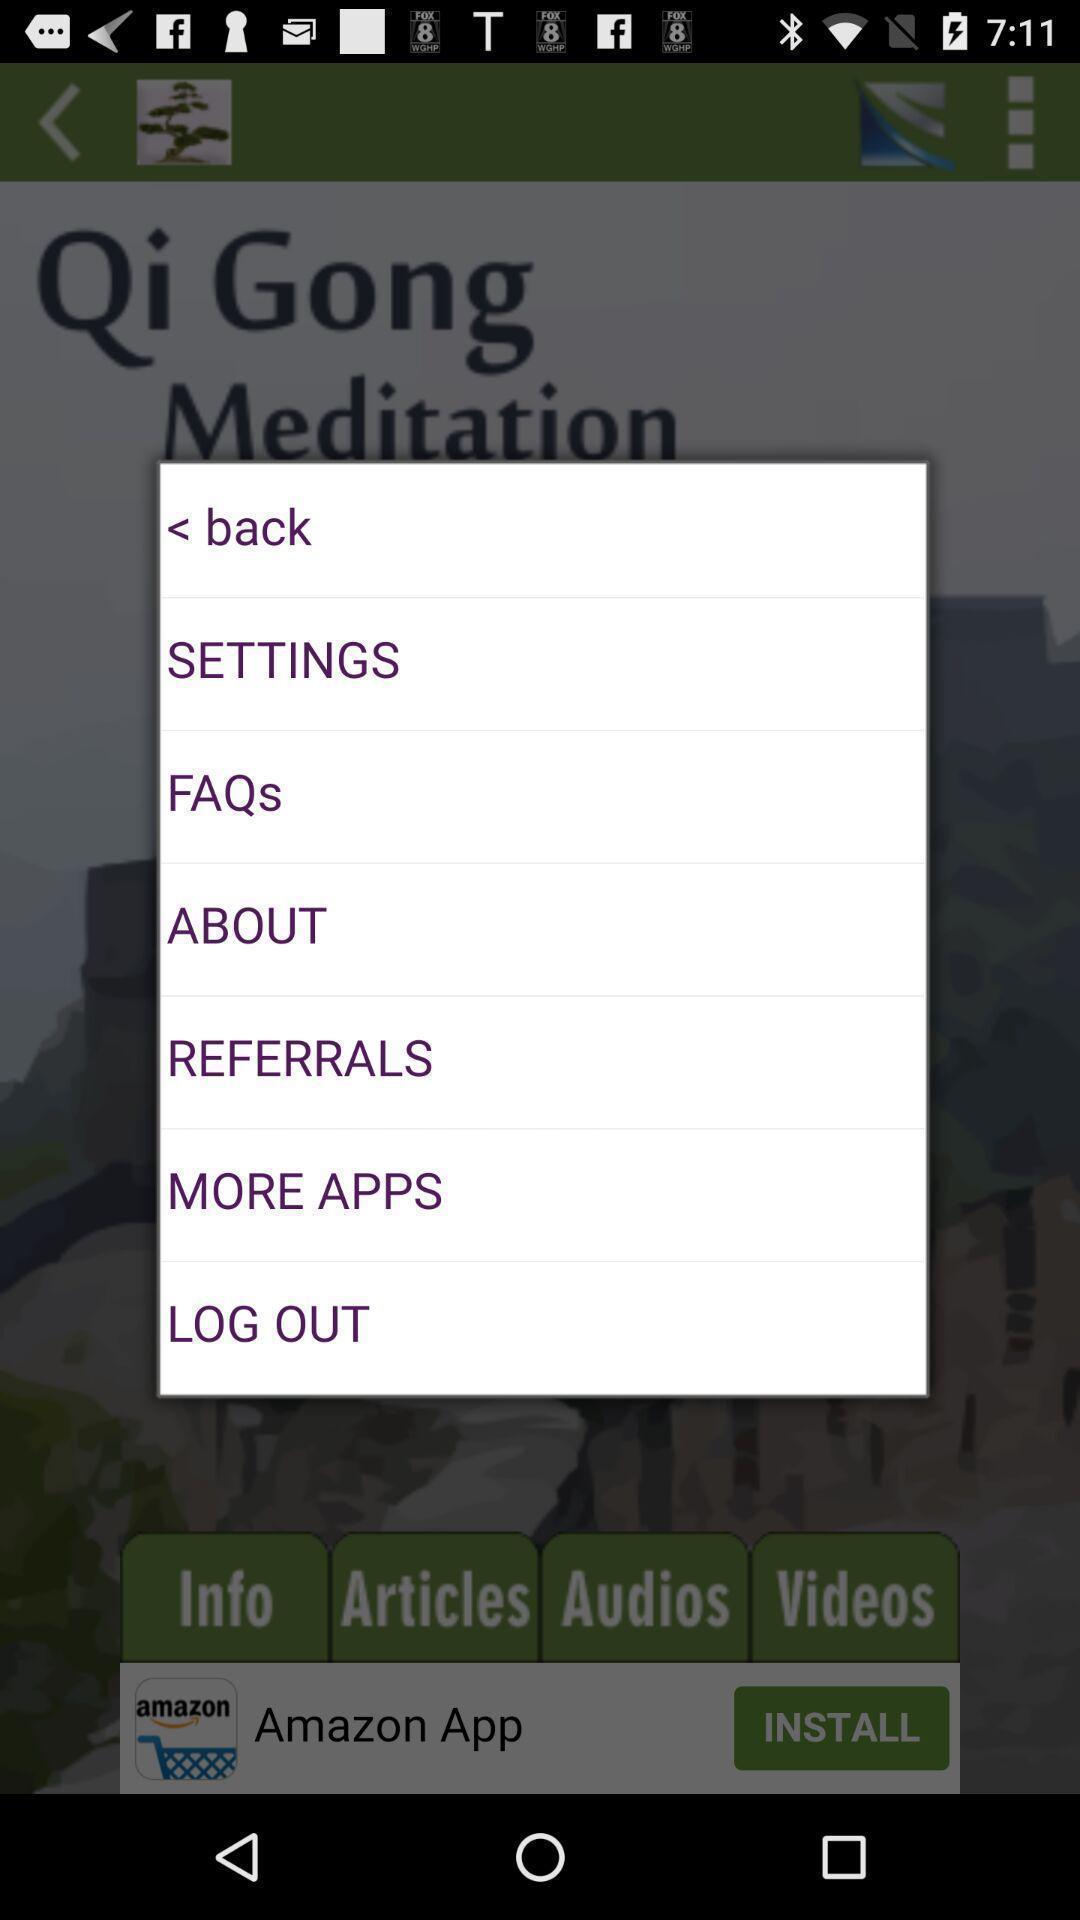Describe the content in this image. Pop-up with list of options. 